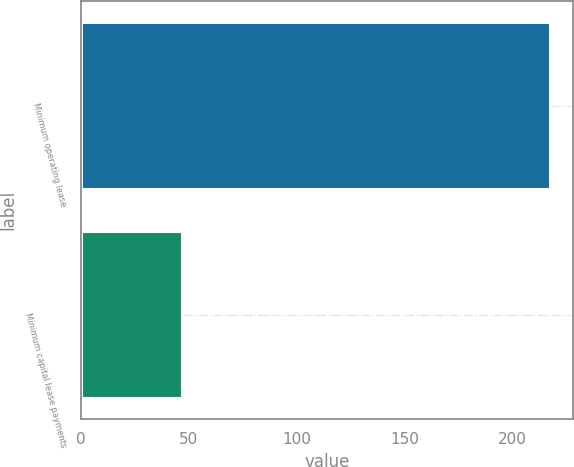Convert chart. <chart><loc_0><loc_0><loc_500><loc_500><bar_chart><fcel>Minimum operating lease<fcel>Minimum capital lease payments<nl><fcel>217<fcel>47<nl></chart> 